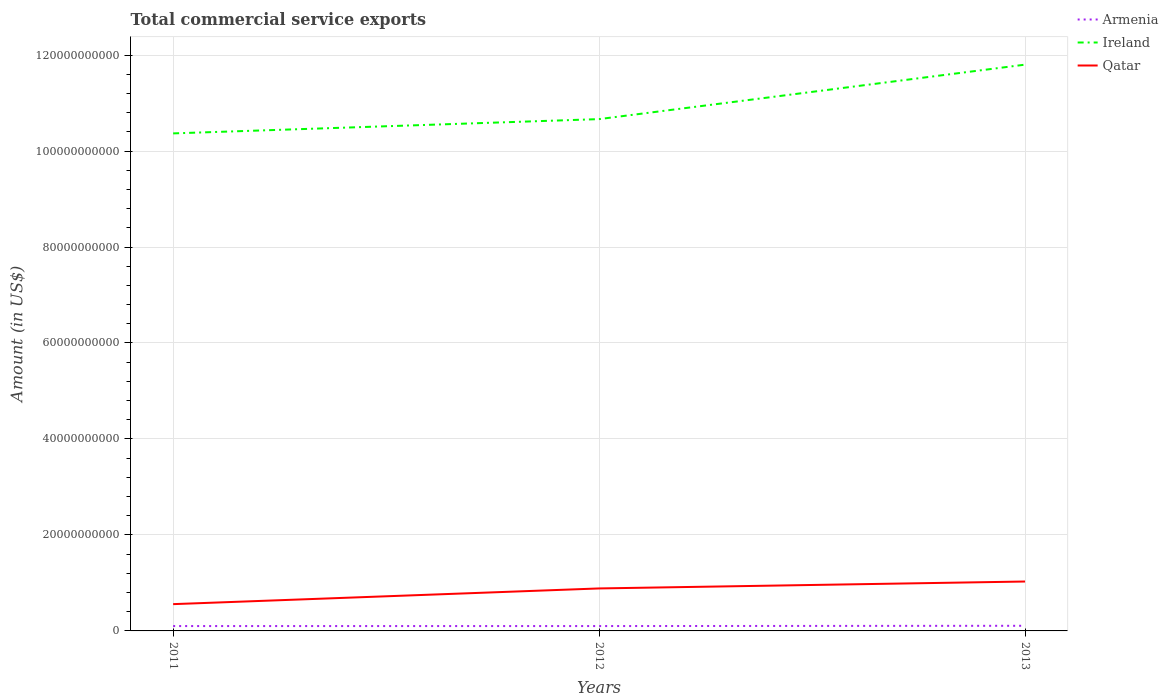Does the line corresponding to Qatar intersect with the line corresponding to Armenia?
Ensure brevity in your answer.  No. Is the number of lines equal to the number of legend labels?
Your response must be concise. Yes. Across all years, what is the maximum total commercial service exports in Qatar?
Give a very brief answer. 5.58e+09. What is the total total commercial service exports in Armenia in the graph?
Offer a terse response. -5.94e+07. What is the difference between the highest and the second highest total commercial service exports in Armenia?
Your response must be concise. 5.94e+07. How many years are there in the graph?
Make the answer very short. 3. Are the values on the major ticks of Y-axis written in scientific E-notation?
Your response must be concise. No. Does the graph contain any zero values?
Provide a short and direct response. No. Where does the legend appear in the graph?
Your answer should be compact. Top right. How are the legend labels stacked?
Offer a very short reply. Vertical. What is the title of the graph?
Ensure brevity in your answer.  Total commercial service exports. What is the label or title of the Y-axis?
Make the answer very short. Amount (in US$). What is the Amount (in US$) of Armenia in 2011?
Your answer should be compact. 1.01e+09. What is the Amount (in US$) in Ireland in 2011?
Provide a succinct answer. 1.04e+11. What is the Amount (in US$) in Qatar in 2011?
Keep it short and to the point. 5.58e+09. What is the Amount (in US$) in Armenia in 2012?
Ensure brevity in your answer.  1.01e+09. What is the Amount (in US$) of Ireland in 2012?
Your response must be concise. 1.07e+11. What is the Amount (in US$) in Qatar in 2012?
Your response must be concise. 8.85e+09. What is the Amount (in US$) of Armenia in 2013?
Make the answer very short. 1.07e+09. What is the Amount (in US$) in Ireland in 2013?
Provide a short and direct response. 1.18e+11. What is the Amount (in US$) of Qatar in 2013?
Keep it short and to the point. 1.03e+1. Across all years, what is the maximum Amount (in US$) in Armenia?
Keep it short and to the point. 1.07e+09. Across all years, what is the maximum Amount (in US$) of Ireland?
Provide a succinct answer. 1.18e+11. Across all years, what is the maximum Amount (in US$) of Qatar?
Provide a short and direct response. 1.03e+1. Across all years, what is the minimum Amount (in US$) in Armenia?
Provide a short and direct response. 1.01e+09. Across all years, what is the minimum Amount (in US$) in Ireland?
Your answer should be compact. 1.04e+11. Across all years, what is the minimum Amount (in US$) of Qatar?
Offer a very short reply. 5.58e+09. What is the total Amount (in US$) of Armenia in the graph?
Provide a succinct answer. 3.09e+09. What is the total Amount (in US$) in Ireland in the graph?
Keep it short and to the point. 3.28e+11. What is the total Amount (in US$) of Qatar in the graph?
Ensure brevity in your answer.  2.47e+1. What is the difference between the Amount (in US$) of Armenia in 2011 and that in 2012?
Your answer should be very brief. -1.08e+06. What is the difference between the Amount (in US$) of Ireland in 2011 and that in 2012?
Keep it short and to the point. -2.98e+09. What is the difference between the Amount (in US$) in Qatar in 2011 and that in 2012?
Offer a terse response. -3.27e+09. What is the difference between the Amount (in US$) in Armenia in 2011 and that in 2013?
Offer a terse response. -5.94e+07. What is the difference between the Amount (in US$) in Ireland in 2011 and that in 2013?
Offer a terse response. -1.43e+1. What is the difference between the Amount (in US$) in Qatar in 2011 and that in 2013?
Offer a very short reply. -4.71e+09. What is the difference between the Amount (in US$) in Armenia in 2012 and that in 2013?
Make the answer very short. -5.83e+07. What is the difference between the Amount (in US$) of Ireland in 2012 and that in 2013?
Give a very brief answer. -1.13e+1. What is the difference between the Amount (in US$) of Qatar in 2012 and that in 2013?
Your answer should be very brief. -1.44e+09. What is the difference between the Amount (in US$) in Armenia in 2011 and the Amount (in US$) in Ireland in 2012?
Offer a terse response. -1.06e+11. What is the difference between the Amount (in US$) of Armenia in 2011 and the Amount (in US$) of Qatar in 2012?
Your response must be concise. -7.84e+09. What is the difference between the Amount (in US$) of Ireland in 2011 and the Amount (in US$) of Qatar in 2012?
Provide a succinct answer. 9.48e+1. What is the difference between the Amount (in US$) in Armenia in 2011 and the Amount (in US$) in Ireland in 2013?
Make the answer very short. -1.17e+11. What is the difference between the Amount (in US$) of Armenia in 2011 and the Amount (in US$) of Qatar in 2013?
Give a very brief answer. -9.28e+09. What is the difference between the Amount (in US$) of Ireland in 2011 and the Amount (in US$) of Qatar in 2013?
Offer a very short reply. 9.34e+1. What is the difference between the Amount (in US$) in Armenia in 2012 and the Amount (in US$) in Ireland in 2013?
Offer a very short reply. -1.17e+11. What is the difference between the Amount (in US$) in Armenia in 2012 and the Amount (in US$) in Qatar in 2013?
Make the answer very short. -9.28e+09. What is the difference between the Amount (in US$) of Ireland in 2012 and the Amount (in US$) of Qatar in 2013?
Your response must be concise. 9.64e+1. What is the average Amount (in US$) of Armenia per year?
Make the answer very short. 1.03e+09. What is the average Amount (in US$) in Ireland per year?
Offer a very short reply. 1.09e+11. What is the average Amount (in US$) in Qatar per year?
Offer a very short reply. 8.24e+09. In the year 2011, what is the difference between the Amount (in US$) of Armenia and Amount (in US$) of Ireland?
Offer a terse response. -1.03e+11. In the year 2011, what is the difference between the Amount (in US$) in Armenia and Amount (in US$) in Qatar?
Offer a terse response. -4.57e+09. In the year 2011, what is the difference between the Amount (in US$) in Ireland and Amount (in US$) in Qatar?
Your response must be concise. 9.81e+1. In the year 2012, what is the difference between the Amount (in US$) of Armenia and Amount (in US$) of Ireland?
Provide a short and direct response. -1.06e+11. In the year 2012, what is the difference between the Amount (in US$) in Armenia and Amount (in US$) in Qatar?
Provide a short and direct response. -7.84e+09. In the year 2012, what is the difference between the Amount (in US$) in Ireland and Amount (in US$) in Qatar?
Provide a short and direct response. 9.78e+1. In the year 2013, what is the difference between the Amount (in US$) of Armenia and Amount (in US$) of Ireland?
Provide a short and direct response. -1.17e+11. In the year 2013, what is the difference between the Amount (in US$) of Armenia and Amount (in US$) of Qatar?
Your response must be concise. -9.22e+09. In the year 2013, what is the difference between the Amount (in US$) in Ireland and Amount (in US$) in Qatar?
Provide a succinct answer. 1.08e+11. What is the ratio of the Amount (in US$) in Armenia in 2011 to that in 2012?
Keep it short and to the point. 1. What is the ratio of the Amount (in US$) in Ireland in 2011 to that in 2012?
Your response must be concise. 0.97. What is the ratio of the Amount (in US$) of Qatar in 2011 to that in 2012?
Keep it short and to the point. 0.63. What is the ratio of the Amount (in US$) in Armenia in 2011 to that in 2013?
Offer a terse response. 0.94. What is the ratio of the Amount (in US$) of Ireland in 2011 to that in 2013?
Offer a terse response. 0.88. What is the ratio of the Amount (in US$) in Qatar in 2011 to that in 2013?
Offer a very short reply. 0.54. What is the ratio of the Amount (in US$) in Armenia in 2012 to that in 2013?
Your answer should be compact. 0.95. What is the ratio of the Amount (in US$) in Ireland in 2012 to that in 2013?
Provide a short and direct response. 0.9. What is the ratio of the Amount (in US$) in Qatar in 2012 to that in 2013?
Give a very brief answer. 0.86. What is the difference between the highest and the second highest Amount (in US$) in Armenia?
Provide a short and direct response. 5.83e+07. What is the difference between the highest and the second highest Amount (in US$) of Ireland?
Make the answer very short. 1.13e+1. What is the difference between the highest and the second highest Amount (in US$) of Qatar?
Your answer should be very brief. 1.44e+09. What is the difference between the highest and the lowest Amount (in US$) of Armenia?
Make the answer very short. 5.94e+07. What is the difference between the highest and the lowest Amount (in US$) in Ireland?
Provide a short and direct response. 1.43e+1. What is the difference between the highest and the lowest Amount (in US$) in Qatar?
Offer a very short reply. 4.71e+09. 